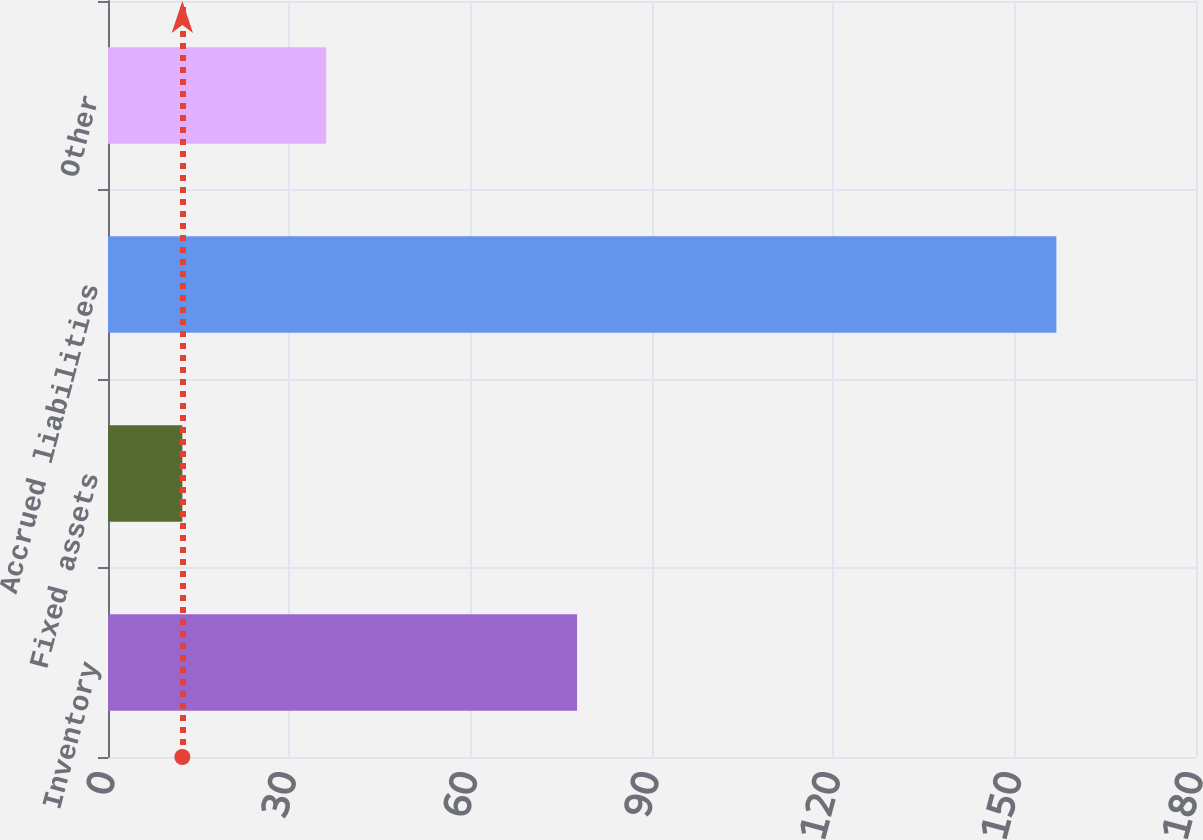<chart> <loc_0><loc_0><loc_500><loc_500><bar_chart><fcel>Inventory<fcel>Fixed assets<fcel>Accrued liabilities<fcel>Other<nl><fcel>77.6<fcel>12.3<fcel>156.9<fcel>36.1<nl></chart> 